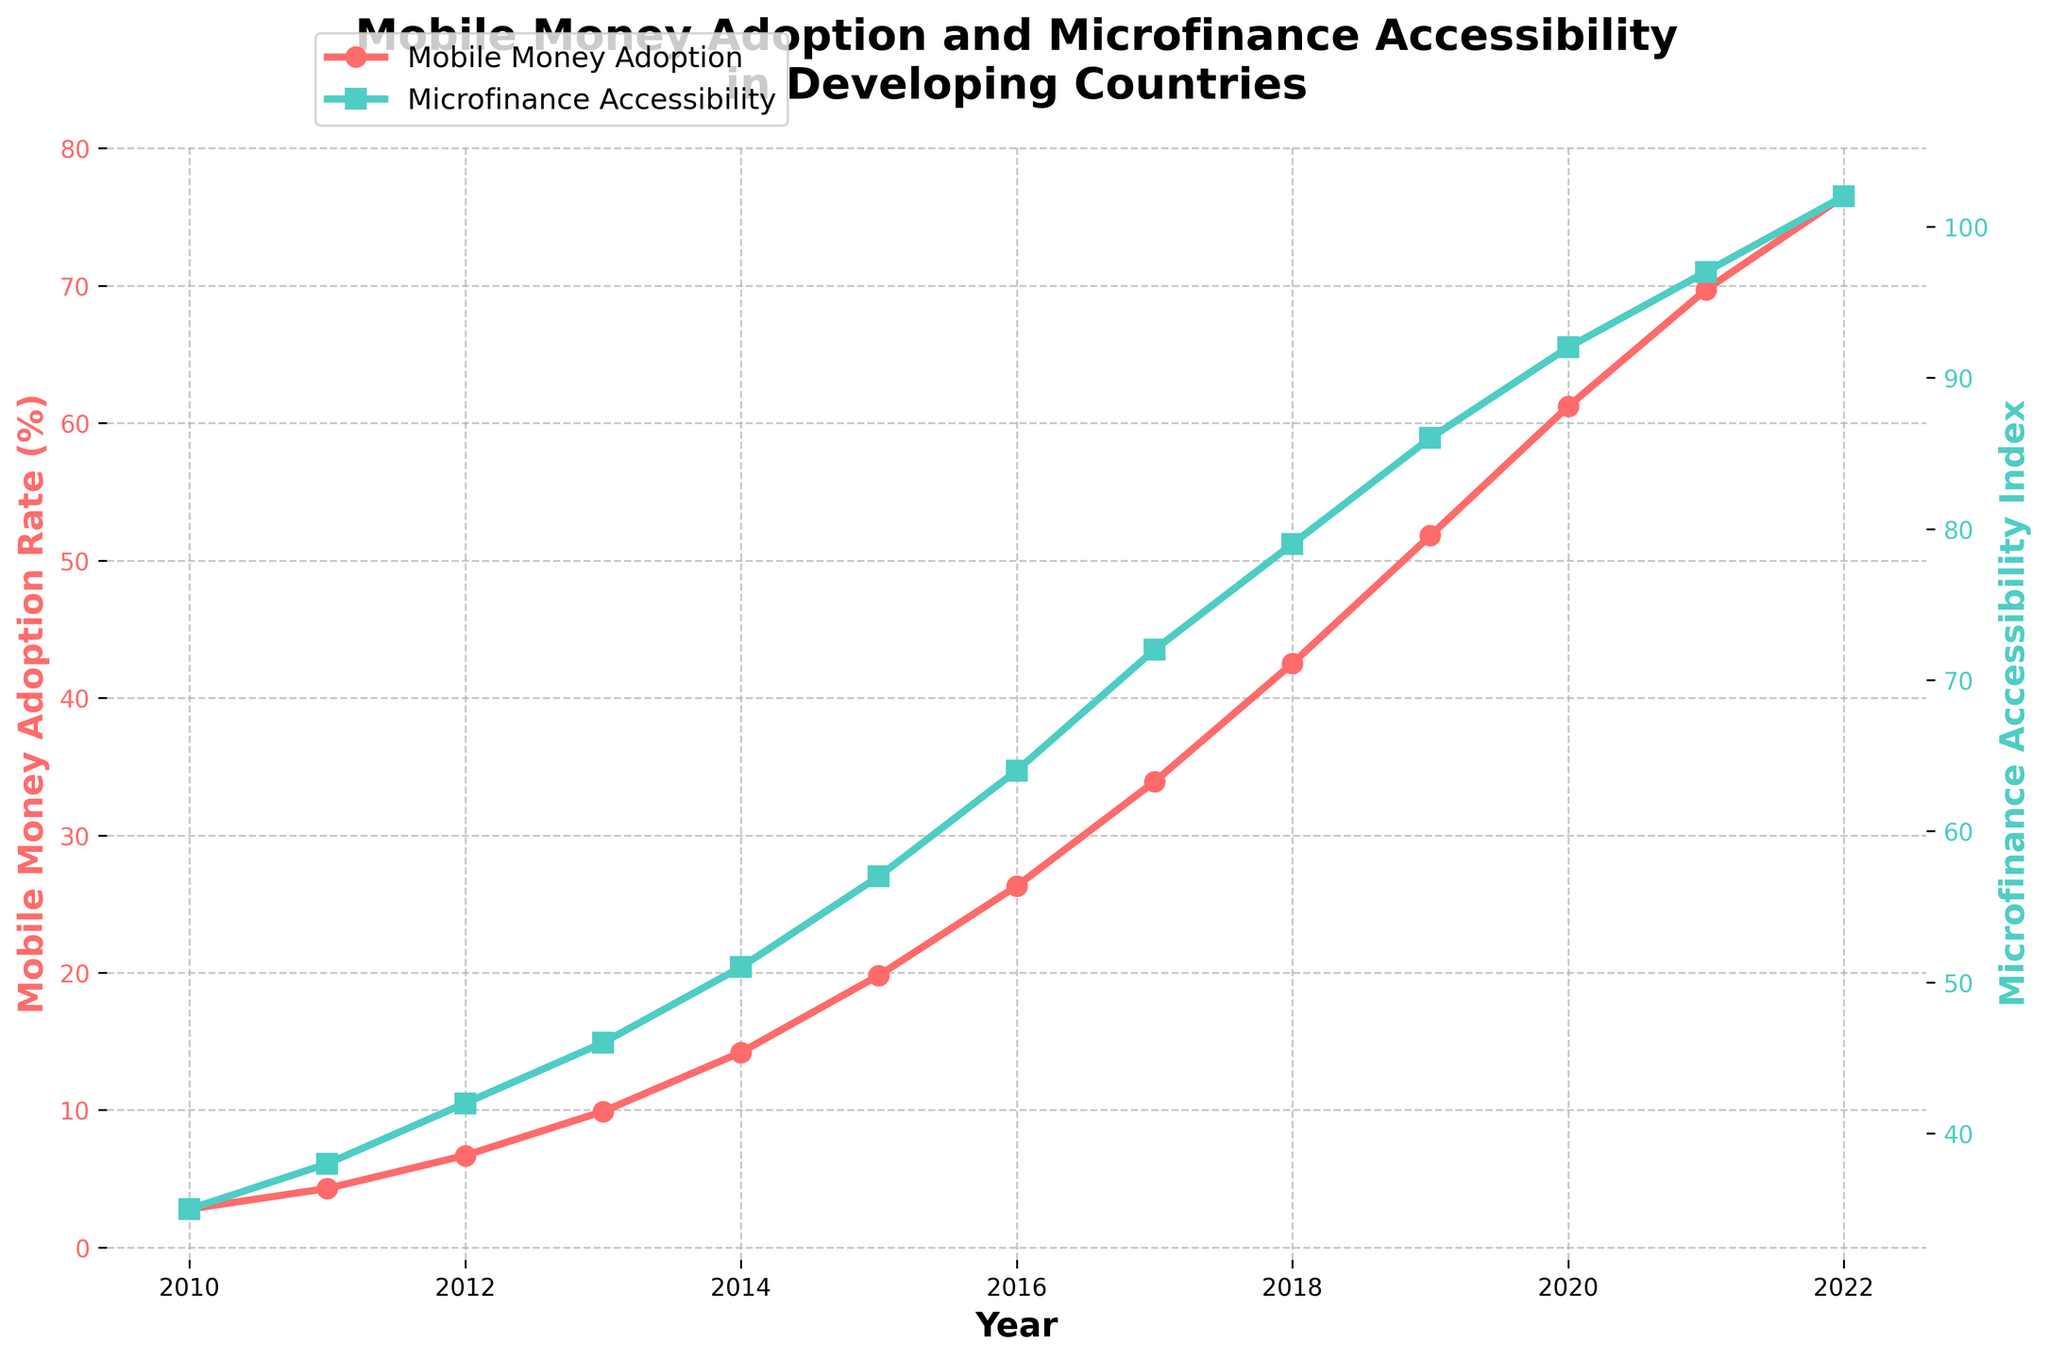What is the mobile money adoption rate in 2015? Look for the year 2015 on the figure and check the red line (representing mobile money adoption rate). The rate is at the corresponding marker point.
Answer: 19.8% In which year did the microfinance accessibility index first exceed 50? Look for the crossing point on the green line (representing microfinance accessibility index) where the y-axis value first goes above 50.
Answer: 2014 How much did the mobile money adoption rate increase from 2010 to 2022? Identify the mobile money adoption rates for 2010 and 2022 on the figure and calculate the difference: 76.5% - 2.8% = 73.7%.
Answer: 73.7% How do the trends of mobile money adoption rate and microfinance accessibility index compare from 2015 to 2020? Observe the slopes of the red and green lines between 2015 to 2020. Both lines show an increasing trend, but the red line (mobile money adoption rate) rises more steeply than the green line (microfinance accessibility index).
Answer: Both increase, but mobile money adoption increases more steeply Between which consecutive years does the mobile money adoption rate show the highest growth? Compare the year-to-year increases for the red line (mobile money adoption rate) and find the largest increment. The highest growth is between 2019 and 2020, which is 61.2% - 51.8% = 9.4%.
Answer: 2019-2020 What is the average microfinance accessibility index for the years 2010, 2015, and 2020? Find the microfinance accessibility indexes for 2010, 2015, and 2020, sum them up, and divide by 3: (35 + 57 + 92) / 3 = 61.3.
Answer: 61.3 In which year do the curves for mobile money adoption rate and microfinance accessibility index cross, if at all? Check the figure to see if and when the red and green lines intersect. They do not intersect in the given data range.
Answer: None Is the growth in the microfinance accessibility index constant over the years? Observe the increment between each year for the green line representing the microfinance accessibility index. The increments vary, showing a general upward trend but not a constant rate.
Answer: No What is the visual difference in the markers used for mobile money adoption rate and microfinance accessibility index? Describe the markers for both lines. The red line uses circular markers while the green line uses square markers.
Answer: Circular for mobile money, square for microfinance Between which consecutive years does the microfinance accessibility index show the smallest growth? Compare the year-to-year increases for the green line (microfinance accessibility index) and find the smallest increment. The smallest growth is between 2021 and 2022, which is 102 - 97 = 5.
Answer: 2021-2022 